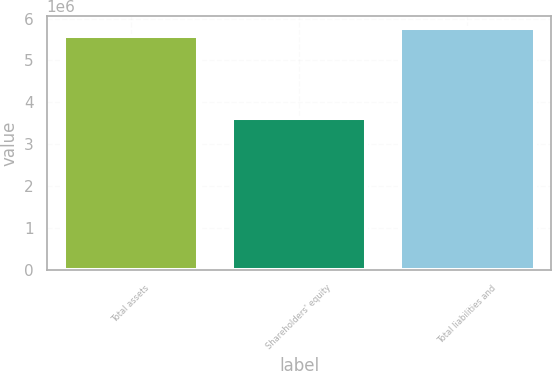<chart> <loc_0><loc_0><loc_500><loc_500><bar_chart><fcel>Total assets<fcel>Shareholders' equity<fcel>Total liabilities and<nl><fcel>5.5816e+06<fcel>3.61668e+06<fcel>5.7781e+06<nl></chart> 